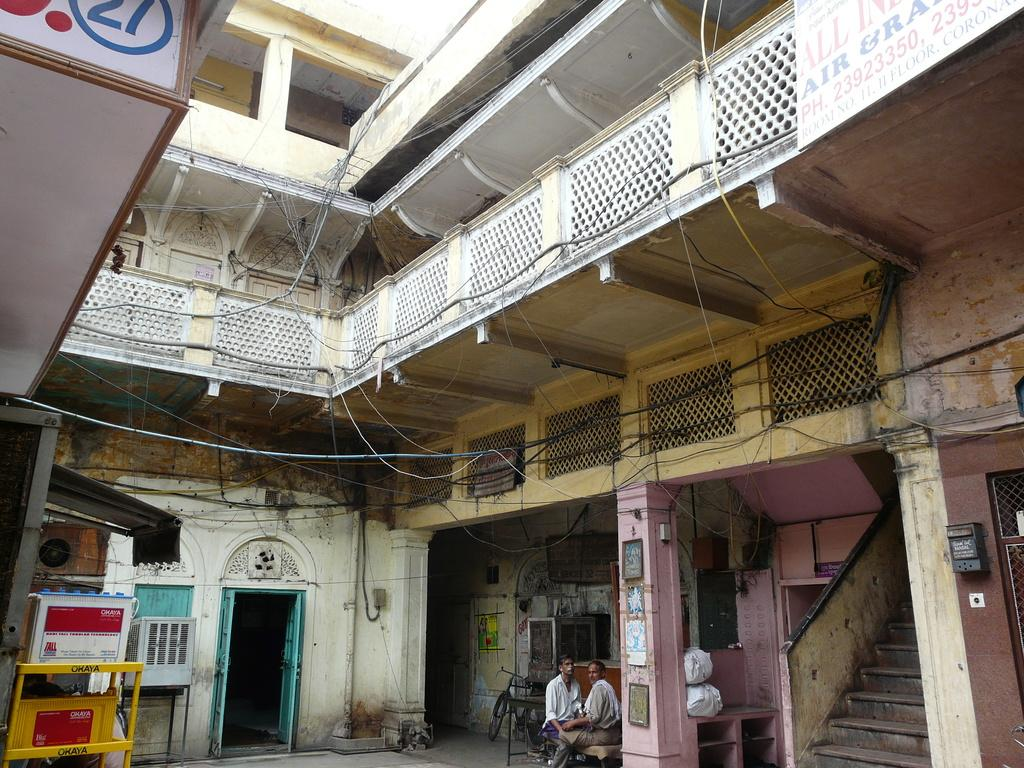What type of structures can be seen in the image? There are buildings in the image. What is present on the left side of the image? There are doors, machines, pillars, wires, and other unspecified objects on the left side of the image. Can you describe the architectural feature on the left side of the image? There is a staircase on the left side of the image. What are the people in the image doing? There are people sitting on chairs in the image. What is the purpose of the fence in the image? The purpose of the fence in the image is not specified, but it could be for security or to separate areas. How deep is the quicksand in the image? There is no quicksand present in the image. What types of toys can be seen in the image? There are no toys present in the image. 